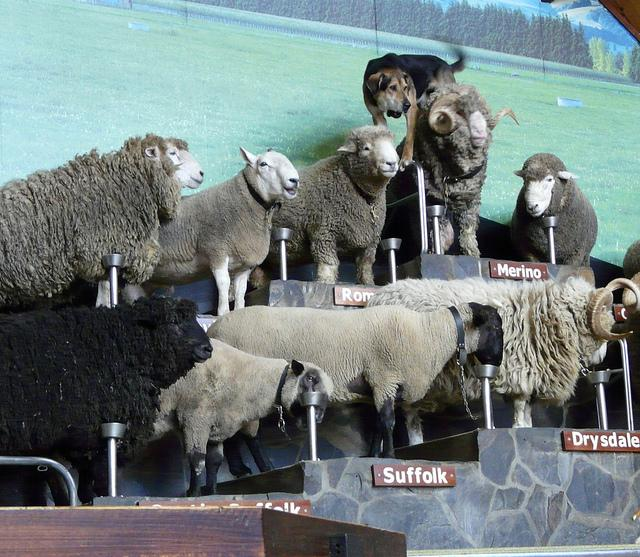Which type of sheep is the highest on the stand?

Choices:
A) drysdale
B) suffolk
C) roma
D) merino merino 